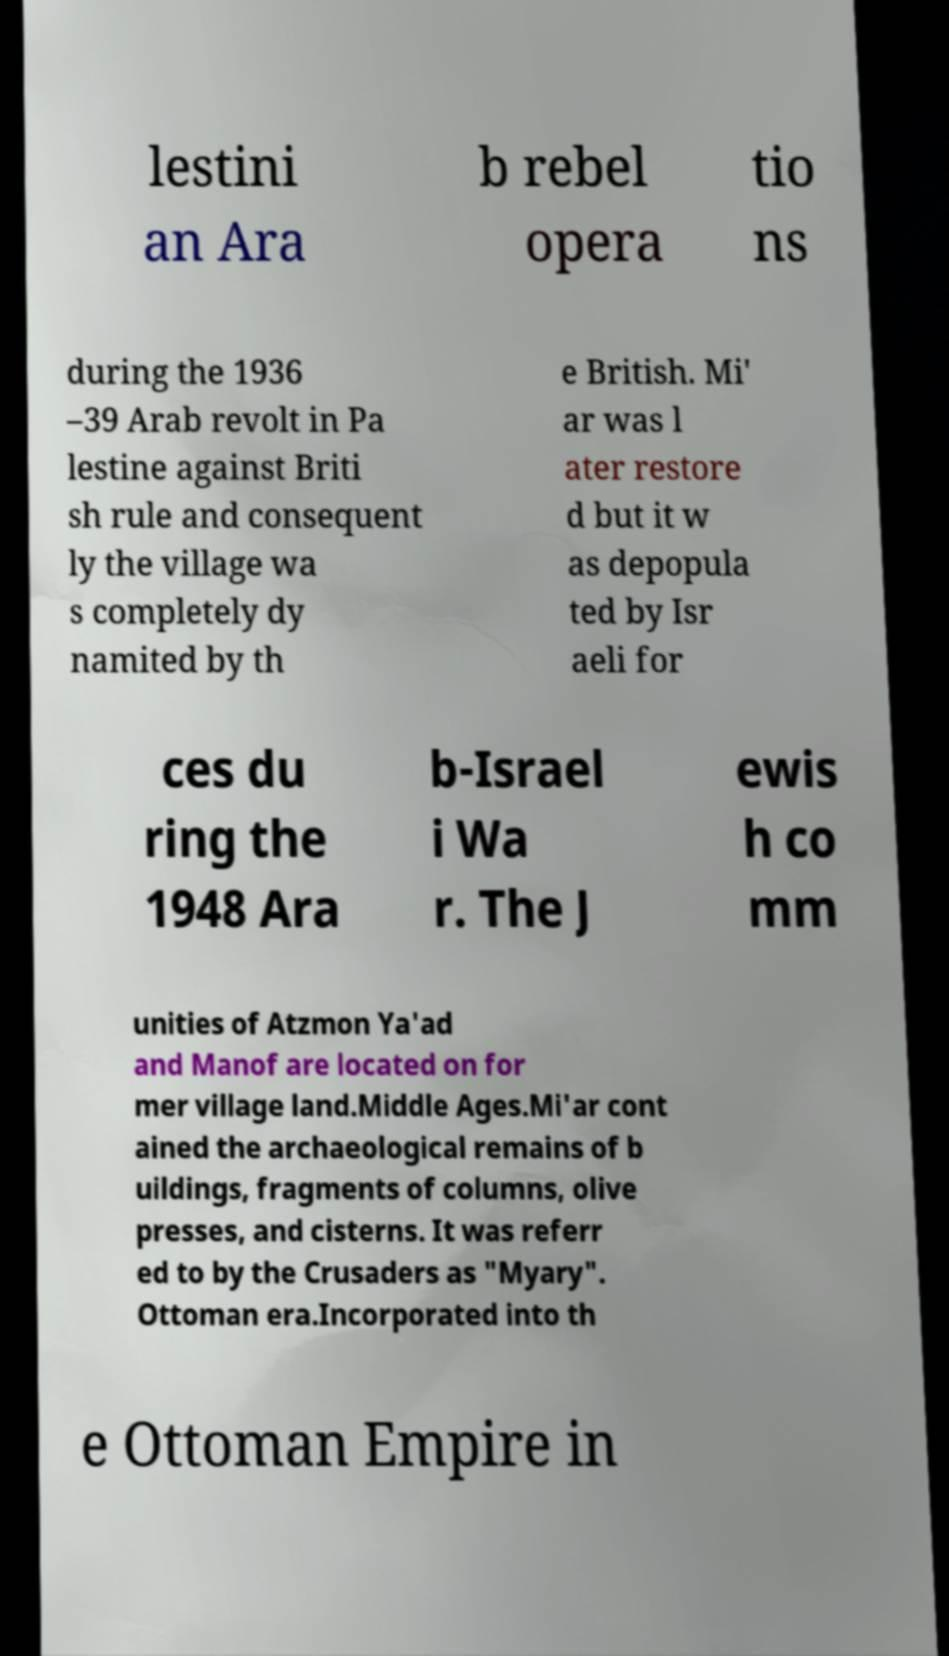Can you accurately transcribe the text from the provided image for me? lestini an Ara b rebel opera tio ns during the 1936 –39 Arab revolt in Pa lestine against Briti sh rule and consequent ly the village wa s completely dy namited by th e British. Mi' ar was l ater restore d but it w as depopula ted by Isr aeli for ces du ring the 1948 Ara b-Israel i Wa r. The J ewis h co mm unities of Atzmon Ya'ad and Manof are located on for mer village land.Middle Ages.Mi'ar cont ained the archaeological remains of b uildings, fragments of columns, olive presses, and cisterns. It was referr ed to by the Crusaders as "Myary". Ottoman era.Incorporated into th e Ottoman Empire in 